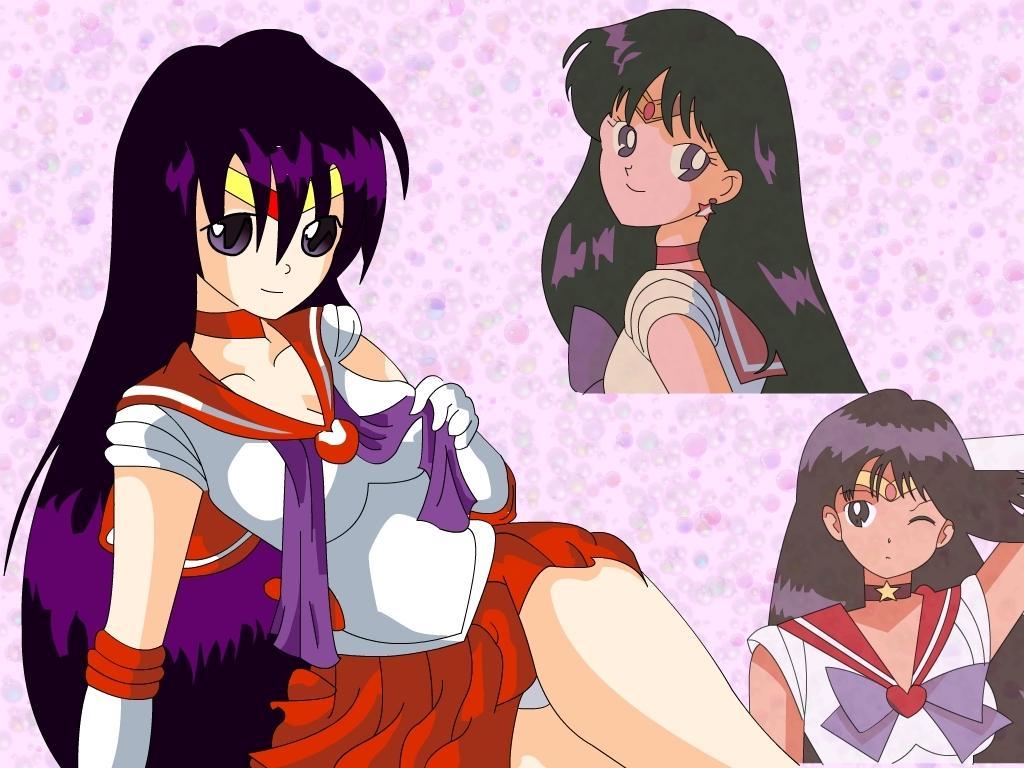In one or two sentences, can you explain what this image depicts? This is an animated picture. Here we can see cartoons. 